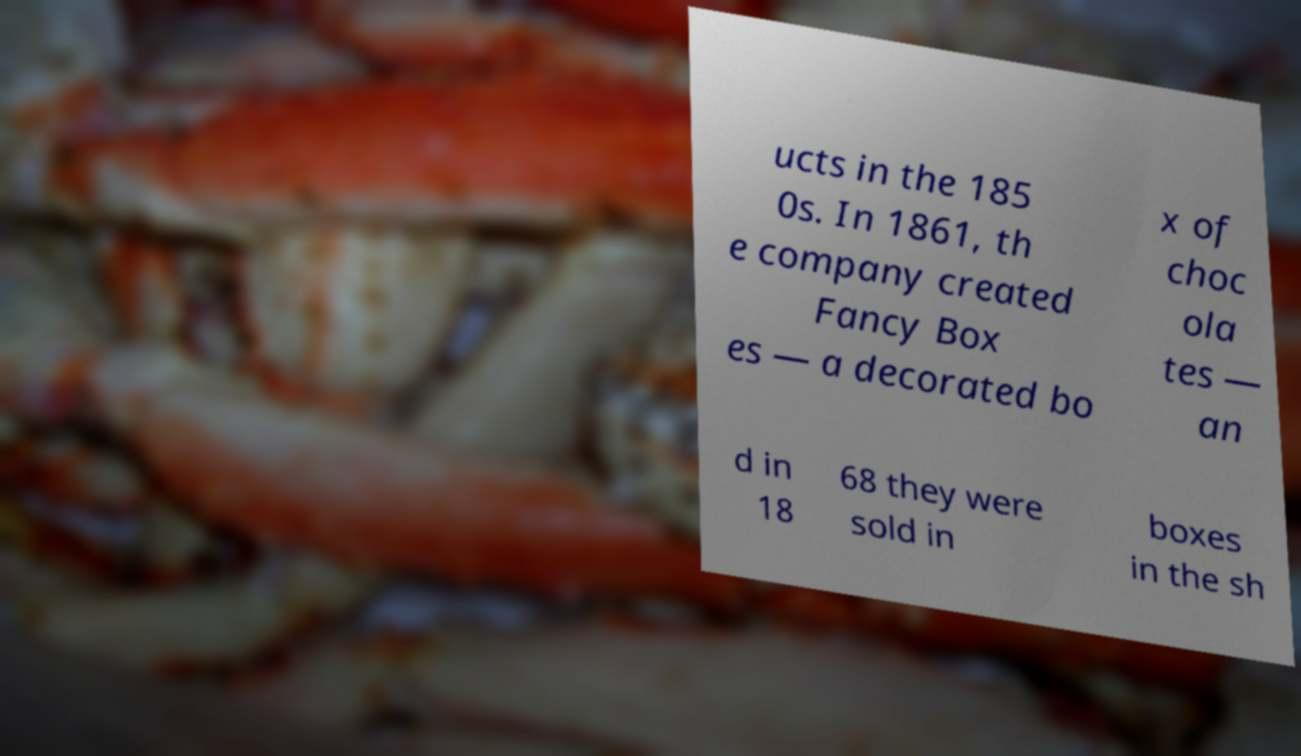I need the written content from this picture converted into text. Can you do that? ucts in the 185 0s. In 1861, th e company created Fancy Box es — a decorated bo x of choc ola tes — an d in 18 68 they were sold in boxes in the sh 